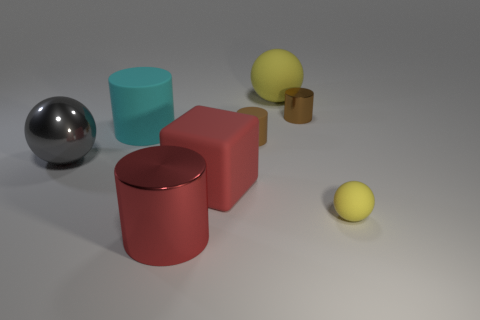Add 1 cyan cylinders. How many objects exist? 9 Subtract all spheres. How many objects are left? 5 Subtract all tiny red metallic balls. Subtract all small yellow balls. How many objects are left? 7 Add 5 large objects. How many large objects are left? 10 Add 7 tiny gray metallic things. How many tiny gray metallic things exist? 7 Subtract 0 purple cubes. How many objects are left? 8 